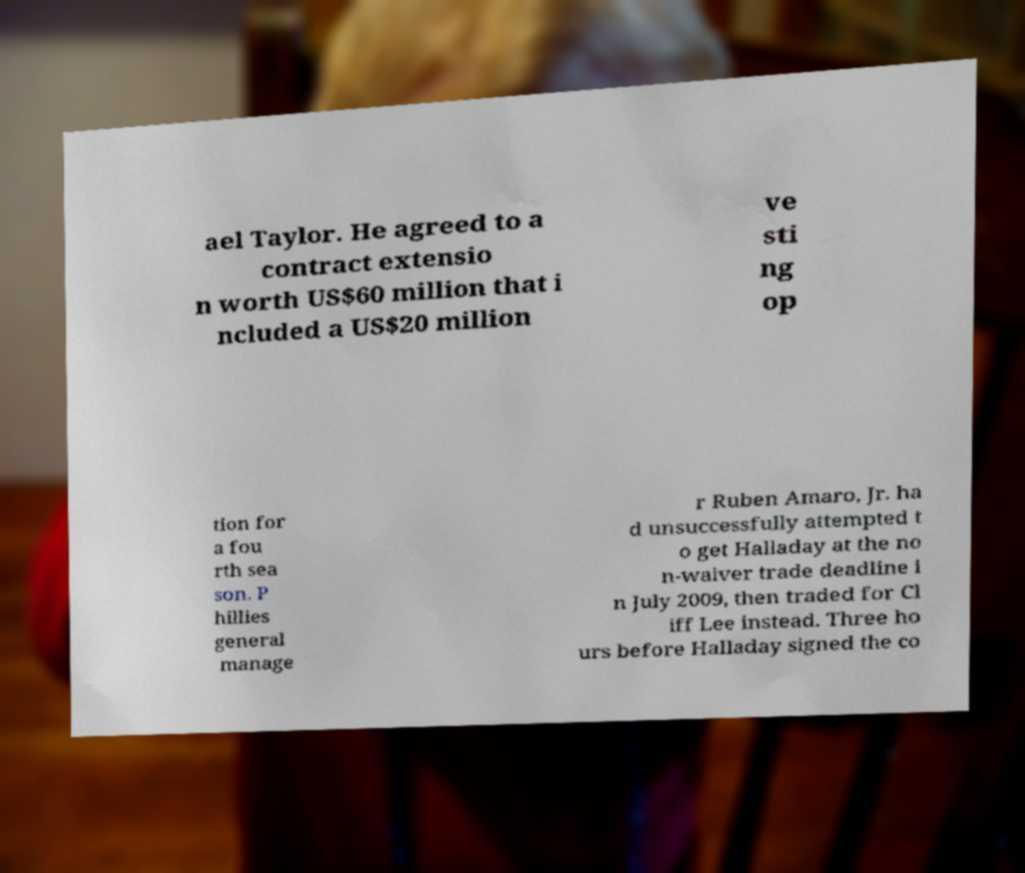Can you read and provide the text displayed in the image?This photo seems to have some interesting text. Can you extract and type it out for me? ael Taylor. He agreed to a contract extensio n worth US$60 million that i ncluded a US$20 million ve sti ng op tion for a fou rth sea son. P hillies general manage r Ruben Amaro, Jr. ha d unsuccessfully attempted t o get Halladay at the no n-waiver trade deadline i n July 2009, then traded for Cl iff Lee instead. Three ho urs before Halladay signed the co 